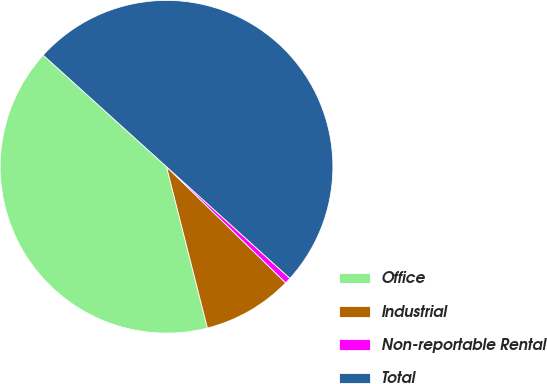<chart> <loc_0><loc_0><loc_500><loc_500><pie_chart><fcel>Office<fcel>Industrial<fcel>Non-reportable Rental<fcel>Total<nl><fcel>40.66%<fcel>8.76%<fcel>0.59%<fcel>50.0%<nl></chart> 